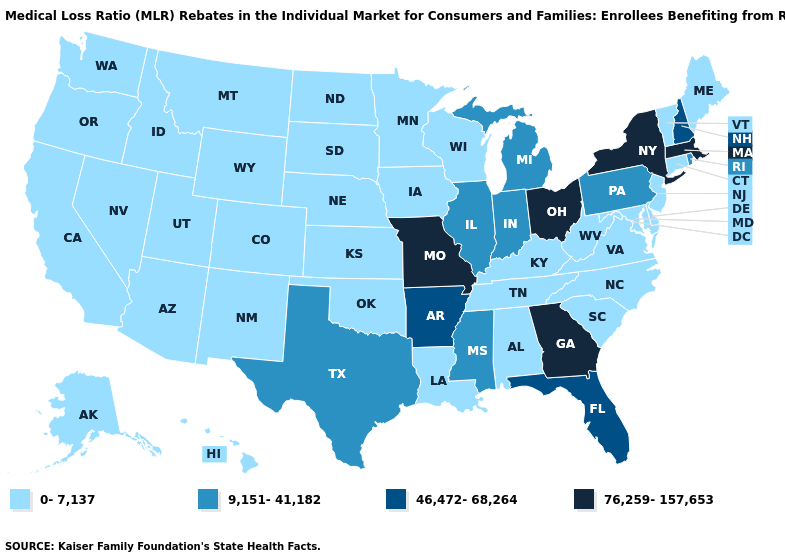What is the value of Louisiana?
Give a very brief answer. 0-7,137. What is the value of Minnesota?
Write a very short answer. 0-7,137. Is the legend a continuous bar?
Concise answer only. No. Name the states that have a value in the range 0-7,137?
Answer briefly. Alabama, Alaska, Arizona, California, Colorado, Connecticut, Delaware, Hawaii, Idaho, Iowa, Kansas, Kentucky, Louisiana, Maine, Maryland, Minnesota, Montana, Nebraska, Nevada, New Jersey, New Mexico, North Carolina, North Dakota, Oklahoma, Oregon, South Carolina, South Dakota, Tennessee, Utah, Vermont, Virginia, Washington, West Virginia, Wisconsin, Wyoming. Name the states that have a value in the range 76,259-157,653?
Write a very short answer. Georgia, Massachusetts, Missouri, New York, Ohio. Name the states that have a value in the range 0-7,137?
Quick response, please. Alabama, Alaska, Arizona, California, Colorado, Connecticut, Delaware, Hawaii, Idaho, Iowa, Kansas, Kentucky, Louisiana, Maine, Maryland, Minnesota, Montana, Nebraska, Nevada, New Jersey, New Mexico, North Carolina, North Dakota, Oklahoma, Oregon, South Carolina, South Dakota, Tennessee, Utah, Vermont, Virginia, Washington, West Virginia, Wisconsin, Wyoming. Is the legend a continuous bar?
Short answer required. No. Among the states that border Missouri , does Kentucky have the lowest value?
Write a very short answer. Yes. What is the value of South Dakota?
Concise answer only. 0-7,137. What is the lowest value in states that border Arizona?
Keep it brief. 0-7,137. What is the lowest value in the West?
Keep it brief. 0-7,137. Which states have the lowest value in the USA?
Be succinct. Alabama, Alaska, Arizona, California, Colorado, Connecticut, Delaware, Hawaii, Idaho, Iowa, Kansas, Kentucky, Louisiana, Maine, Maryland, Minnesota, Montana, Nebraska, Nevada, New Jersey, New Mexico, North Carolina, North Dakota, Oklahoma, Oregon, South Carolina, South Dakota, Tennessee, Utah, Vermont, Virginia, Washington, West Virginia, Wisconsin, Wyoming. Does the first symbol in the legend represent the smallest category?
Give a very brief answer. Yes. Name the states that have a value in the range 76,259-157,653?
Short answer required. Georgia, Massachusetts, Missouri, New York, Ohio. 